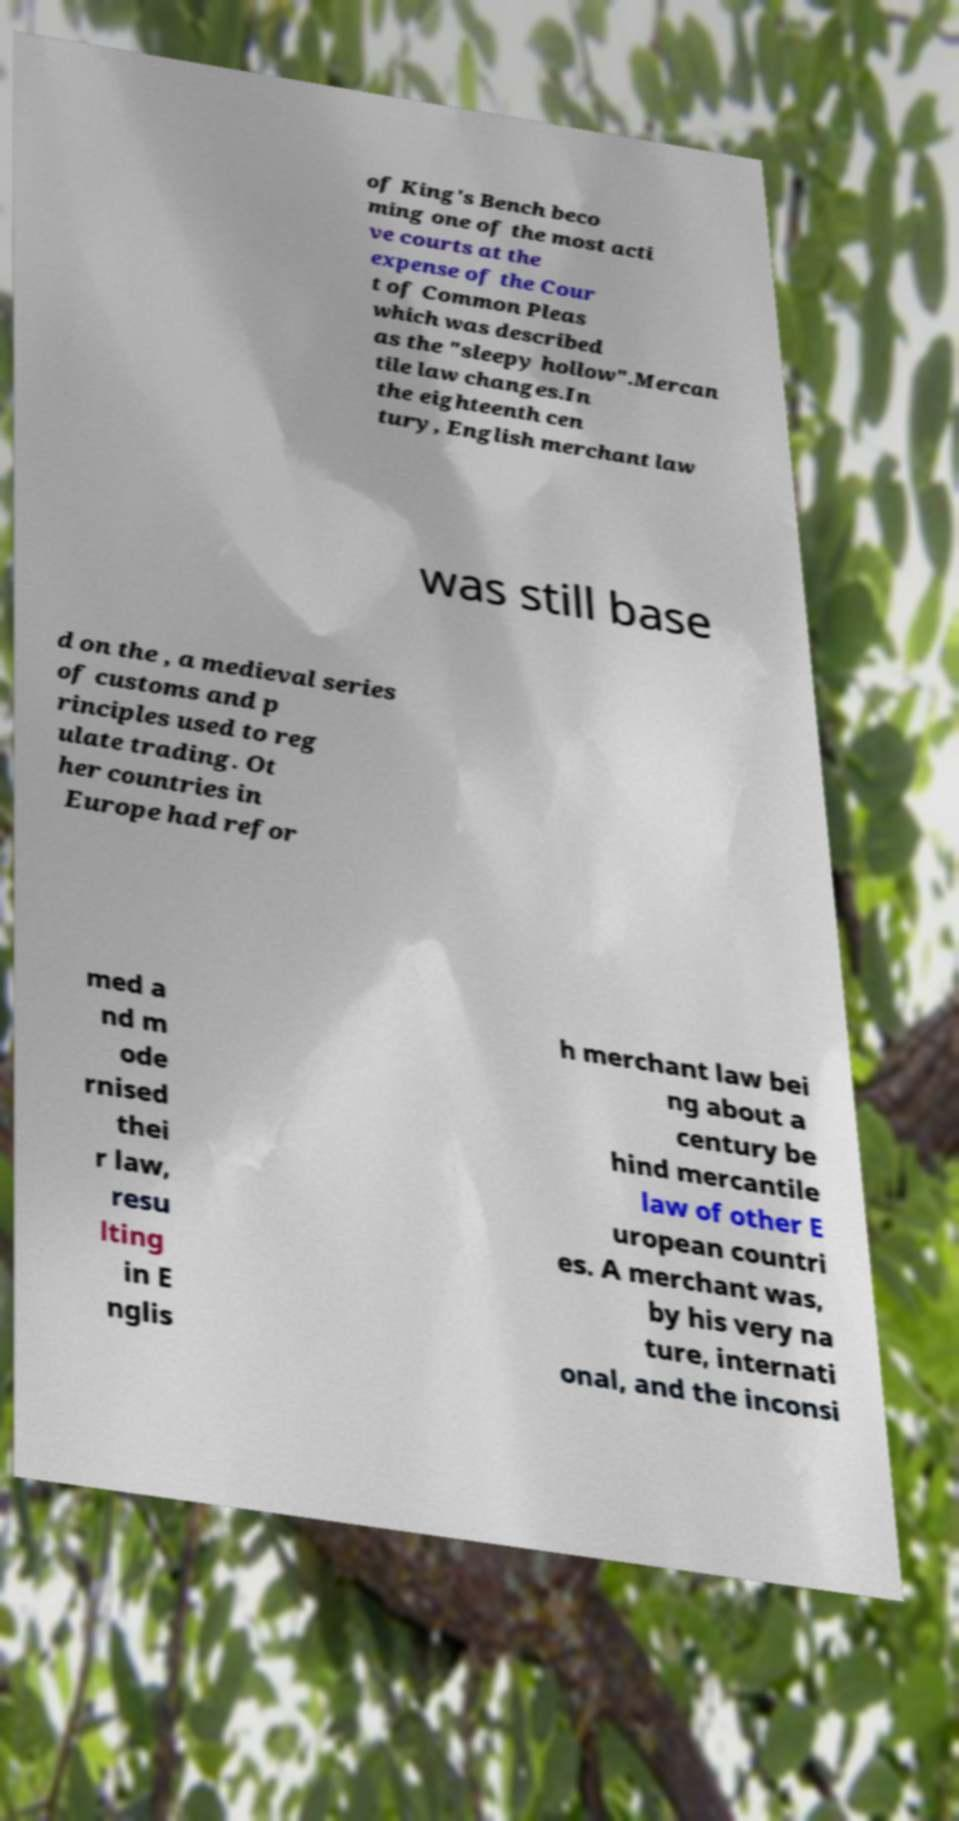For documentation purposes, I need the text within this image transcribed. Could you provide that? of King's Bench beco ming one of the most acti ve courts at the expense of the Cour t of Common Pleas which was described as the "sleepy hollow".Mercan tile law changes.In the eighteenth cen tury, English merchant law was still base d on the , a medieval series of customs and p rinciples used to reg ulate trading. Ot her countries in Europe had refor med a nd m ode rnised thei r law, resu lting in E nglis h merchant law bei ng about a century be hind mercantile law of other E uropean countri es. A merchant was, by his very na ture, internati onal, and the inconsi 